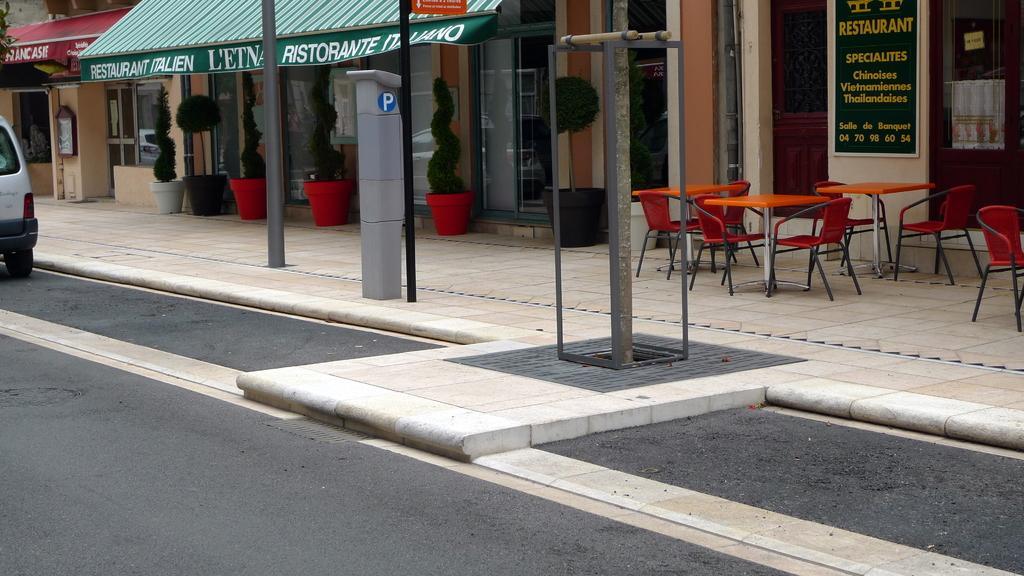Could you give a brief overview of what you see in this image? There is a vehicle on the road. Here we can see poles, chairs, tables, boards, and stalls. 